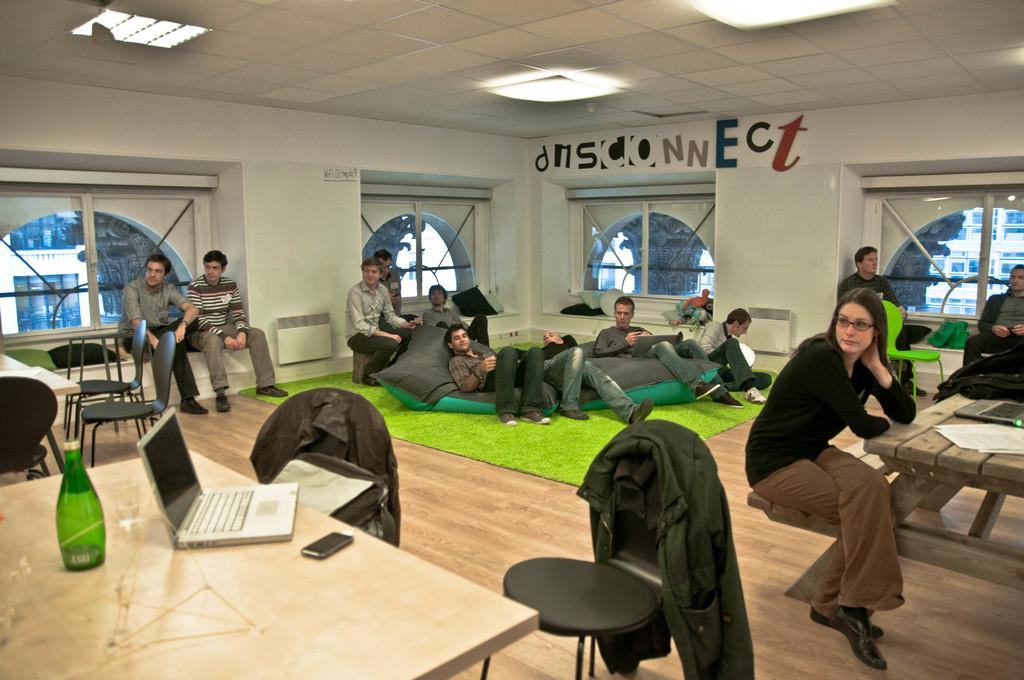What are the people in the image doing? The people in the image are sitting. What objects can be seen on the table in the image? There is a bottle, a laptop, and a mobile phone on the table in the image. What type of furniture is present in the image? There are chairs in the image. What can be seen through the window in the image? A building is visible through the window in the image. What direction is the wind blowing in the image? There is no indication of wind in the image. What type of liquid is visible in the image? There is no liquid visible in the image. Is there a boat present in the image? No, there is no boat present in the image. 